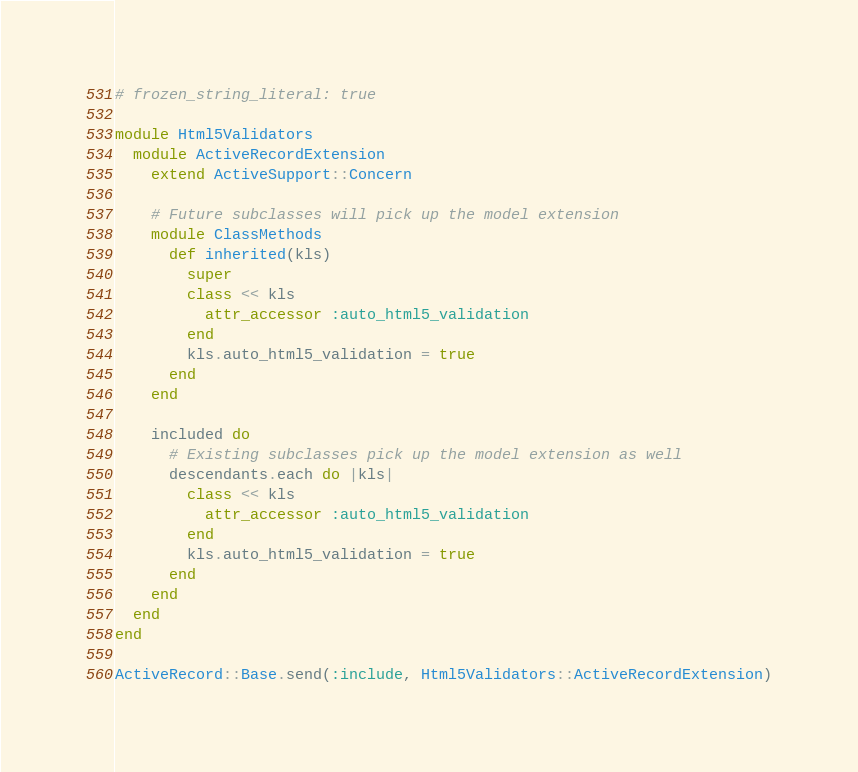<code> <loc_0><loc_0><loc_500><loc_500><_Ruby_># frozen_string_literal: true

module Html5Validators
  module ActiveRecordExtension
    extend ActiveSupport::Concern

    # Future subclasses will pick up the model extension
    module ClassMethods
      def inherited(kls)
        super
        class << kls
          attr_accessor :auto_html5_validation
        end
        kls.auto_html5_validation = true
      end
    end

    included do
      # Existing subclasses pick up the model extension as well
      descendants.each do |kls|
        class << kls
          attr_accessor :auto_html5_validation
        end
        kls.auto_html5_validation = true
      end
    end
  end
end

ActiveRecord::Base.send(:include, Html5Validators::ActiveRecordExtension)
</code> 